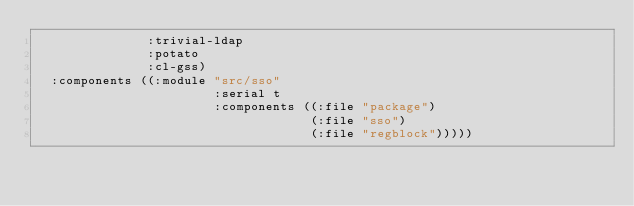Convert code to text. <code><loc_0><loc_0><loc_500><loc_500><_Lisp_>               :trivial-ldap
               :potato
               :cl-gss)
  :components ((:module "src/sso"
                        :serial t
                        :components ((:file "package")
                                     (:file "sso")
                                     (:file "regblock")))))
</code> 